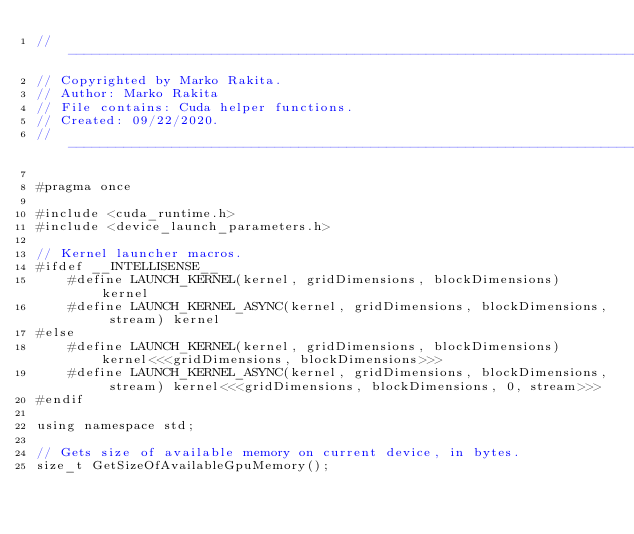Convert code to text. <code><loc_0><loc_0><loc_500><loc_500><_Cuda_>// ----------------------------------------------------------------------------------------------------
// Copyrighted by Marko Rakita.
// Author: Marko Rakita
// File contains: Cuda helper functions.
// Created: 09/22/2020.
// ----------------------------------------------------------------------------------------------------

#pragma once

#include <cuda_runtime.h>
#include <device_launch_parameters.h>

// Kernel launcher macros.
#ifdef __INTELLISENSE__
    #define LAUNCH_KERNEL(kernel, gridDimensions, blockDimensions) kernel
    #define LAUNCH_KERNEL_ASYNC(kernel, gridDimensions, blockDimensions, stream) kernel
#else
    #define LAUNCH_KERNEL(kernel, gridDimensions, blockDimensions) kernel<<<gridDimensions, blockDimensions>>>
    #define LAUNCH_KERNEL_ASYNC(kernel, gridDimensions, blockDimensions, stream) kernel<<<gridDimensions, blockDimensions, 0, stream>>>
#endif

using namespace std;

// Gets size of available memory on current device, in bytes.
size_t GetSizeOfAvailableGpuMemory();</code> 